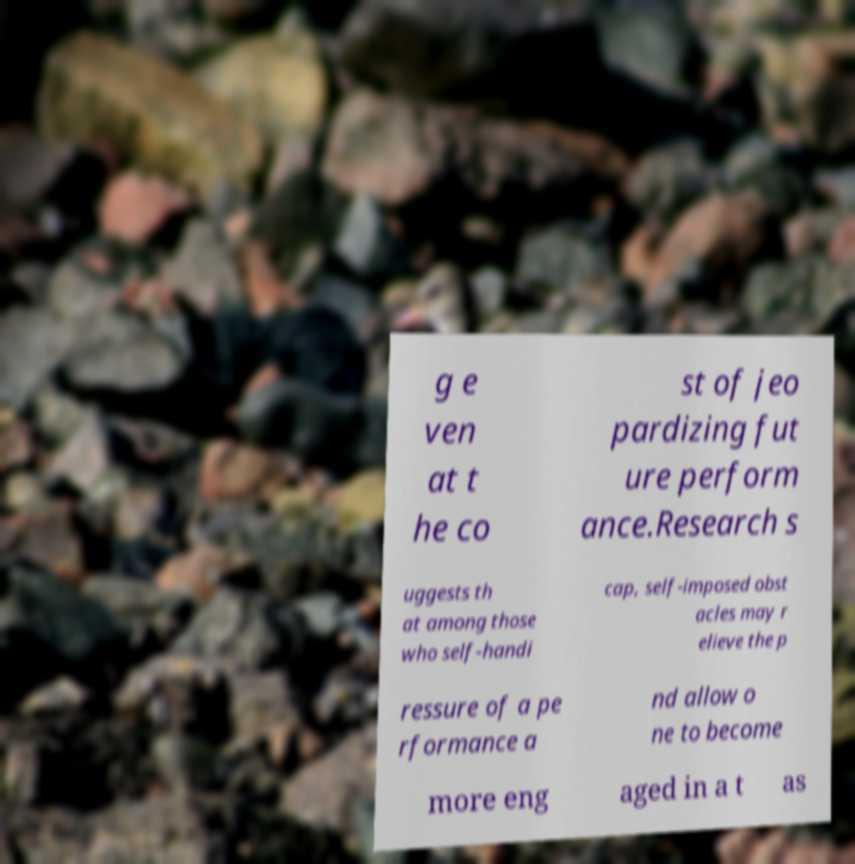What messages or text are displayed in this image? I need them in a readable, typed format. g e ven at t he co st of jeo pardizing fut ure perform ance.Research s uggests th at among those who self-handi cap, self-imposed obst acles may r elieve the p ressure of a pe rformance a nd allow o ne to become more eng aged in a t as 